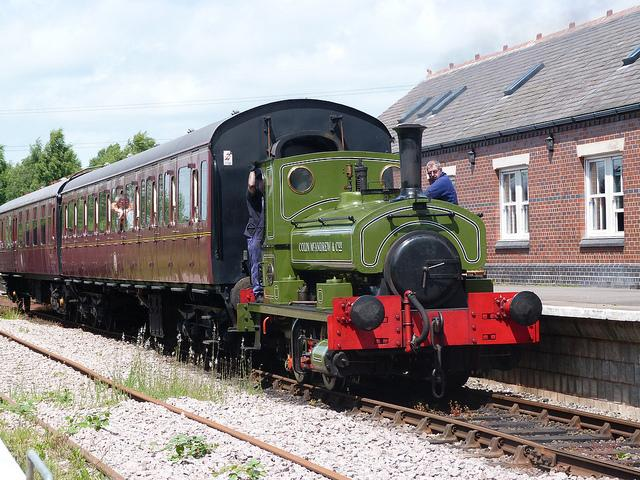What years was this machine first introduced? 1804 